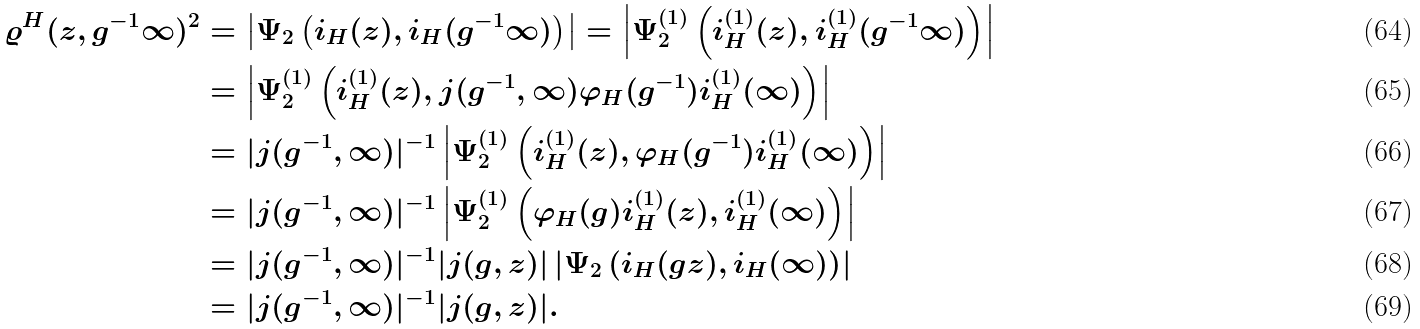Convert formula to latex. <formula><loc_0><loc_0><loc_500><loc_500>\varrho ^ { H } ( z , g ^ { - 1 } \infty ) ^ { 2 } & = \left | \Psi _ { 2 } \left ( i _ { H } ( z ) , i _ { H } ( g ^ { - 1 } \infty ) \right ) \right | = \left | \Psi _ { 2 } ^ { ( 1 ) } \left ( i _ { H } ^ { ( 1 ) } ( z ) , i _ { H } ^ { ( 1 ) } ( g ^ { - 1 } \infty ) \right ) \right | \\ & = \left | \Psi _ { 2 } ^ { ( 1 ) } \left ( i _ { H } ^ { ( 1 ) } ( z ) , j ( g ^ { - 1 } , \infty ) \varphi _ { H } ( g ^ { - 1 } ) i _ { H } ^ { ( 1 ) } ( \infty ) \right ) \right | \\ & = | j ( g ^ { - 1 } , \infty ) | ^ { - 1 } \left | \Psi _ { 2 } ^ { ( 1 ) } \left ( i _ { H } ^ { ( 1 ) } ( z ) , \varphi _ { H } ( g ^ { - 1 } ) i _ { H } ^ { ( 1 ) } ( \infty ) \right ) \right | \\ & = | j ( g ^ { - 1 } , \infty ) | ^ { - 1 } \left | \Psi _ { 2 } ^ { ( 1 ) } \left ( \varphi _ { H } ( g ) i _ { H } ^ { ( 1 ) } ( z ) , i _ { H } ^ { ( 1 ) } ( \infty ) \right ) \right | \\ & = | j ( g ^ { - 1 } , \infty ) | ^ { - 1 } | j ( g , z ) | \left | \Psi _ { 2 } \left ( i _ { H } ( g z ) , i _ { H } ( \infty ) \right ) \right | \\ & = | j ( g ^ { - 1 } , \infty ) | ^ { - 1 } | j ( g , z ) | .</formula> 